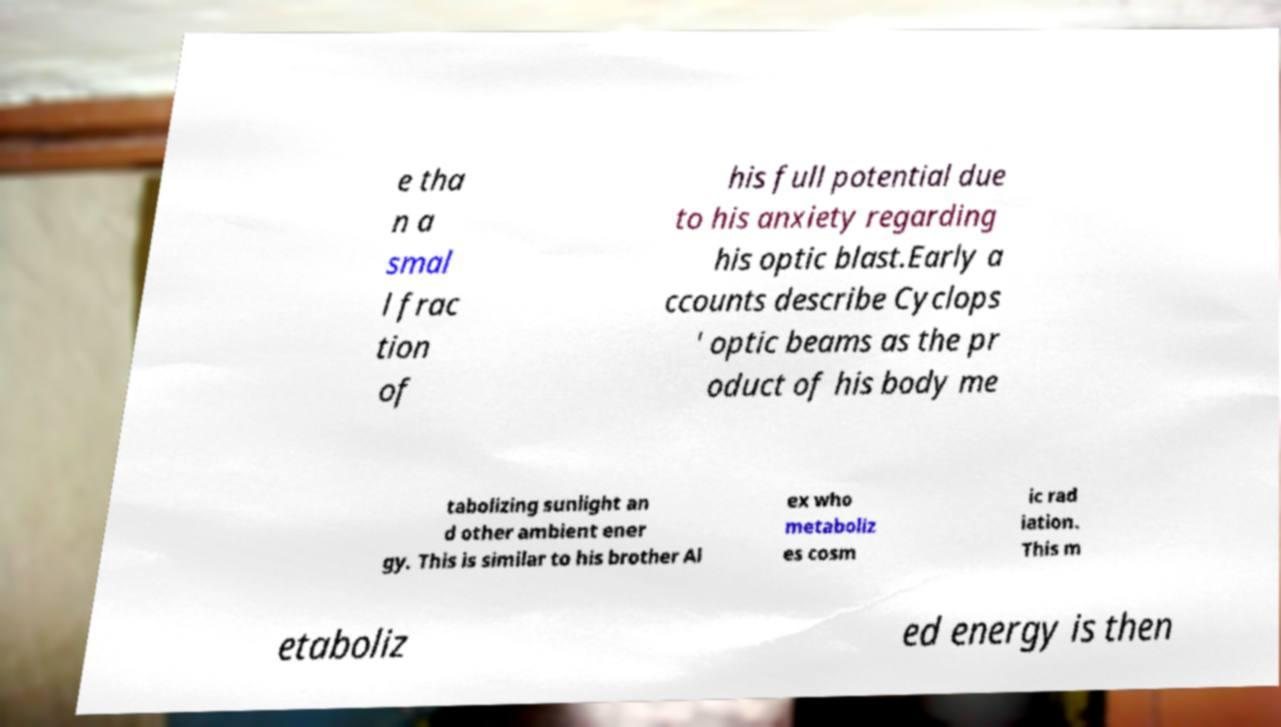Can you accurately transcribe the text from the provided image for me? e tha n a smal l frac tion of his full potential due to his anxiety regarding his optic blast.Early a ccounts describe Cyclops ' optic beams as the pr oduct of his body me tabolizing sunlight an d other ambient ener gy. This is similar to his brother Al ex who metaboliz es cosm ic rad iation. This m etaboliz ed energy is then 